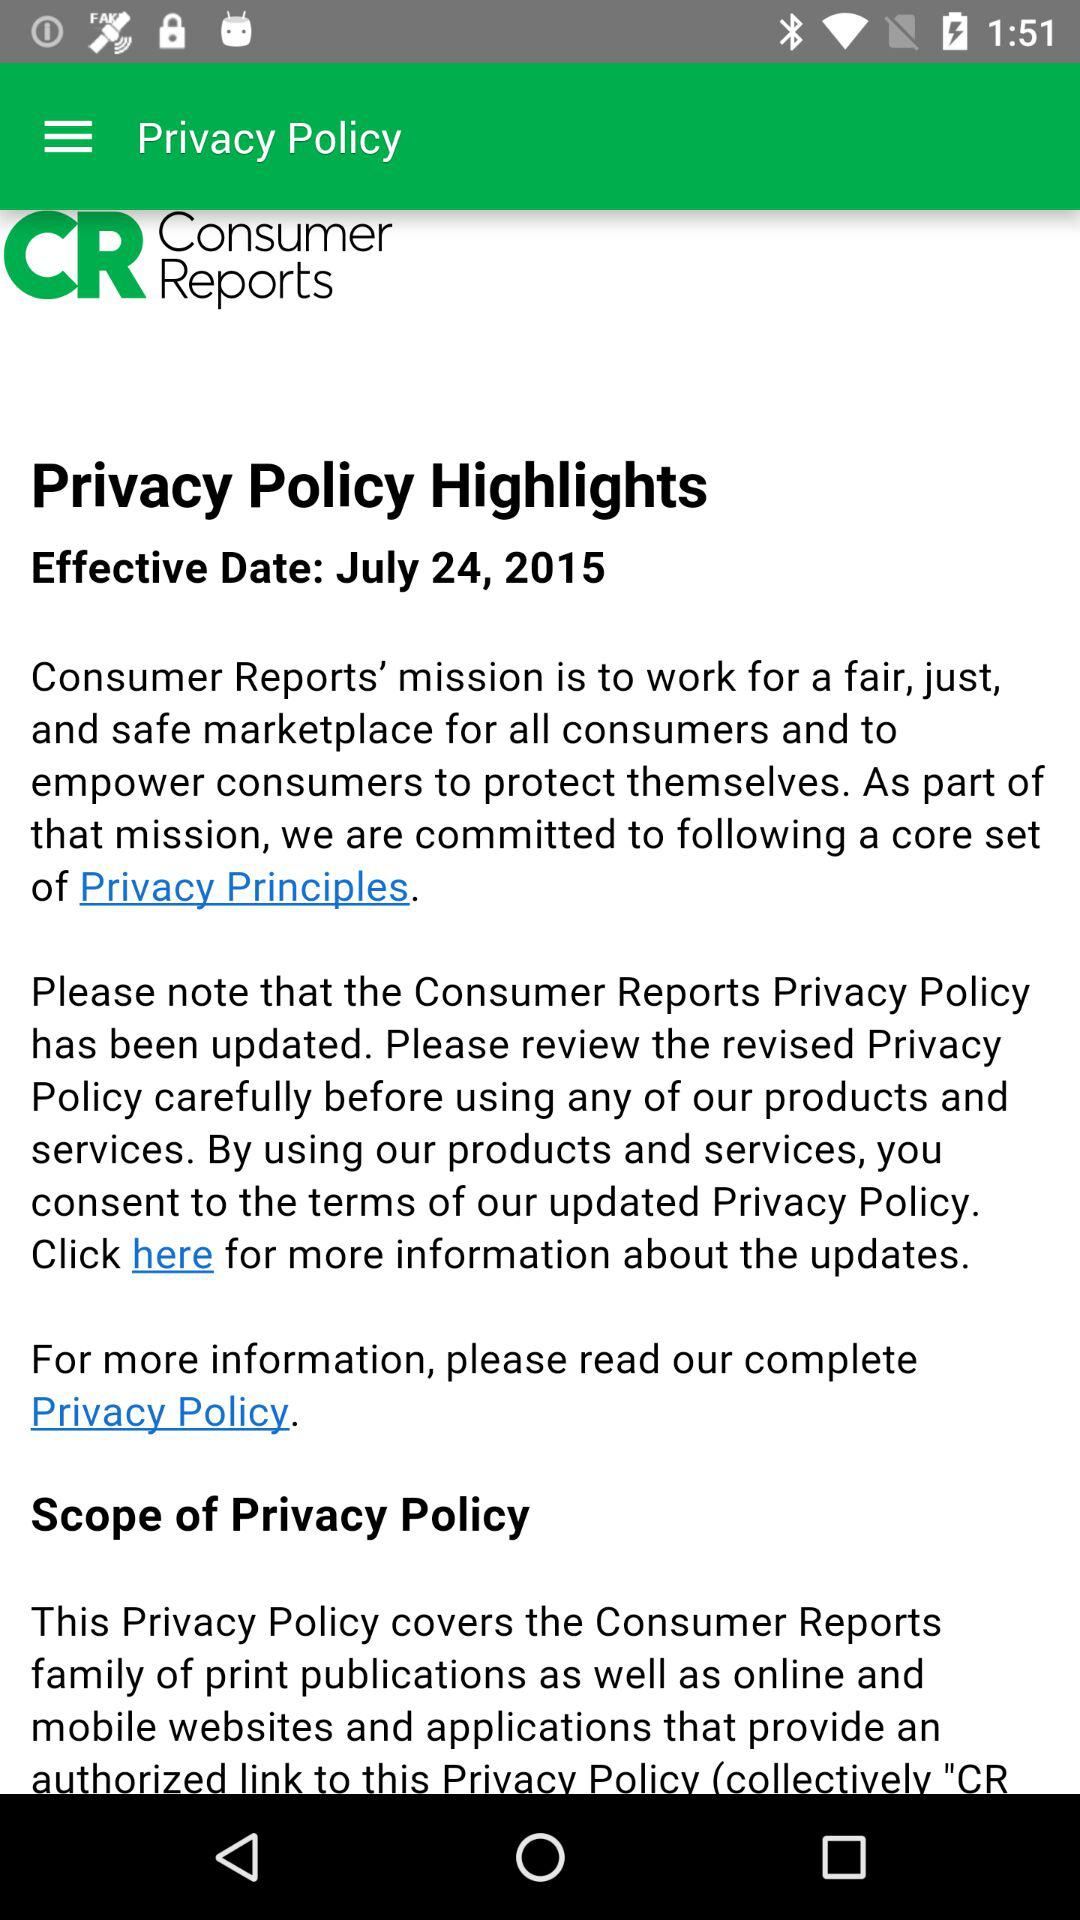What is the mission of Consumer Reports?
Answer the question using a single word or phrase. "Consumer Reports' mission is to work for a fair, just, and safe marketplace for all consumers and to empower consumers to protect themselves." 